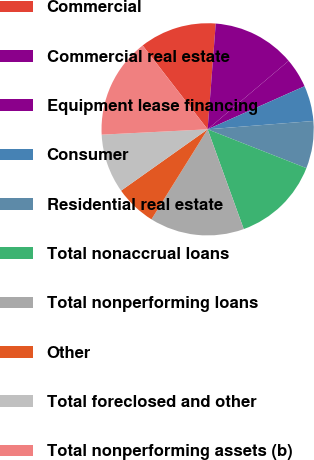<chart> <loc_0><loc_0><loc_500><loc_500><pie_chart><fcel>Commercial<fcel>Commercial real estate<fcel>Equipment lease financing<fcel>Consumer<fcel>Residential real estate<fcel>Total nonaccrual loans<fcel>Total nonperforming loans<fcel>Other<fcel>Total foreclosed and other<fcel>Total nonperforming assets (b)<nl><fcel>11.71%<fcel>12.61%<fcel>4.51%<fcel>5.41%<fcel>7.21%<fcel>13.51%<fcel>14.41%<fcel>6.31%<fcel>9.01%<fcel>15.31%<nl></chart> 